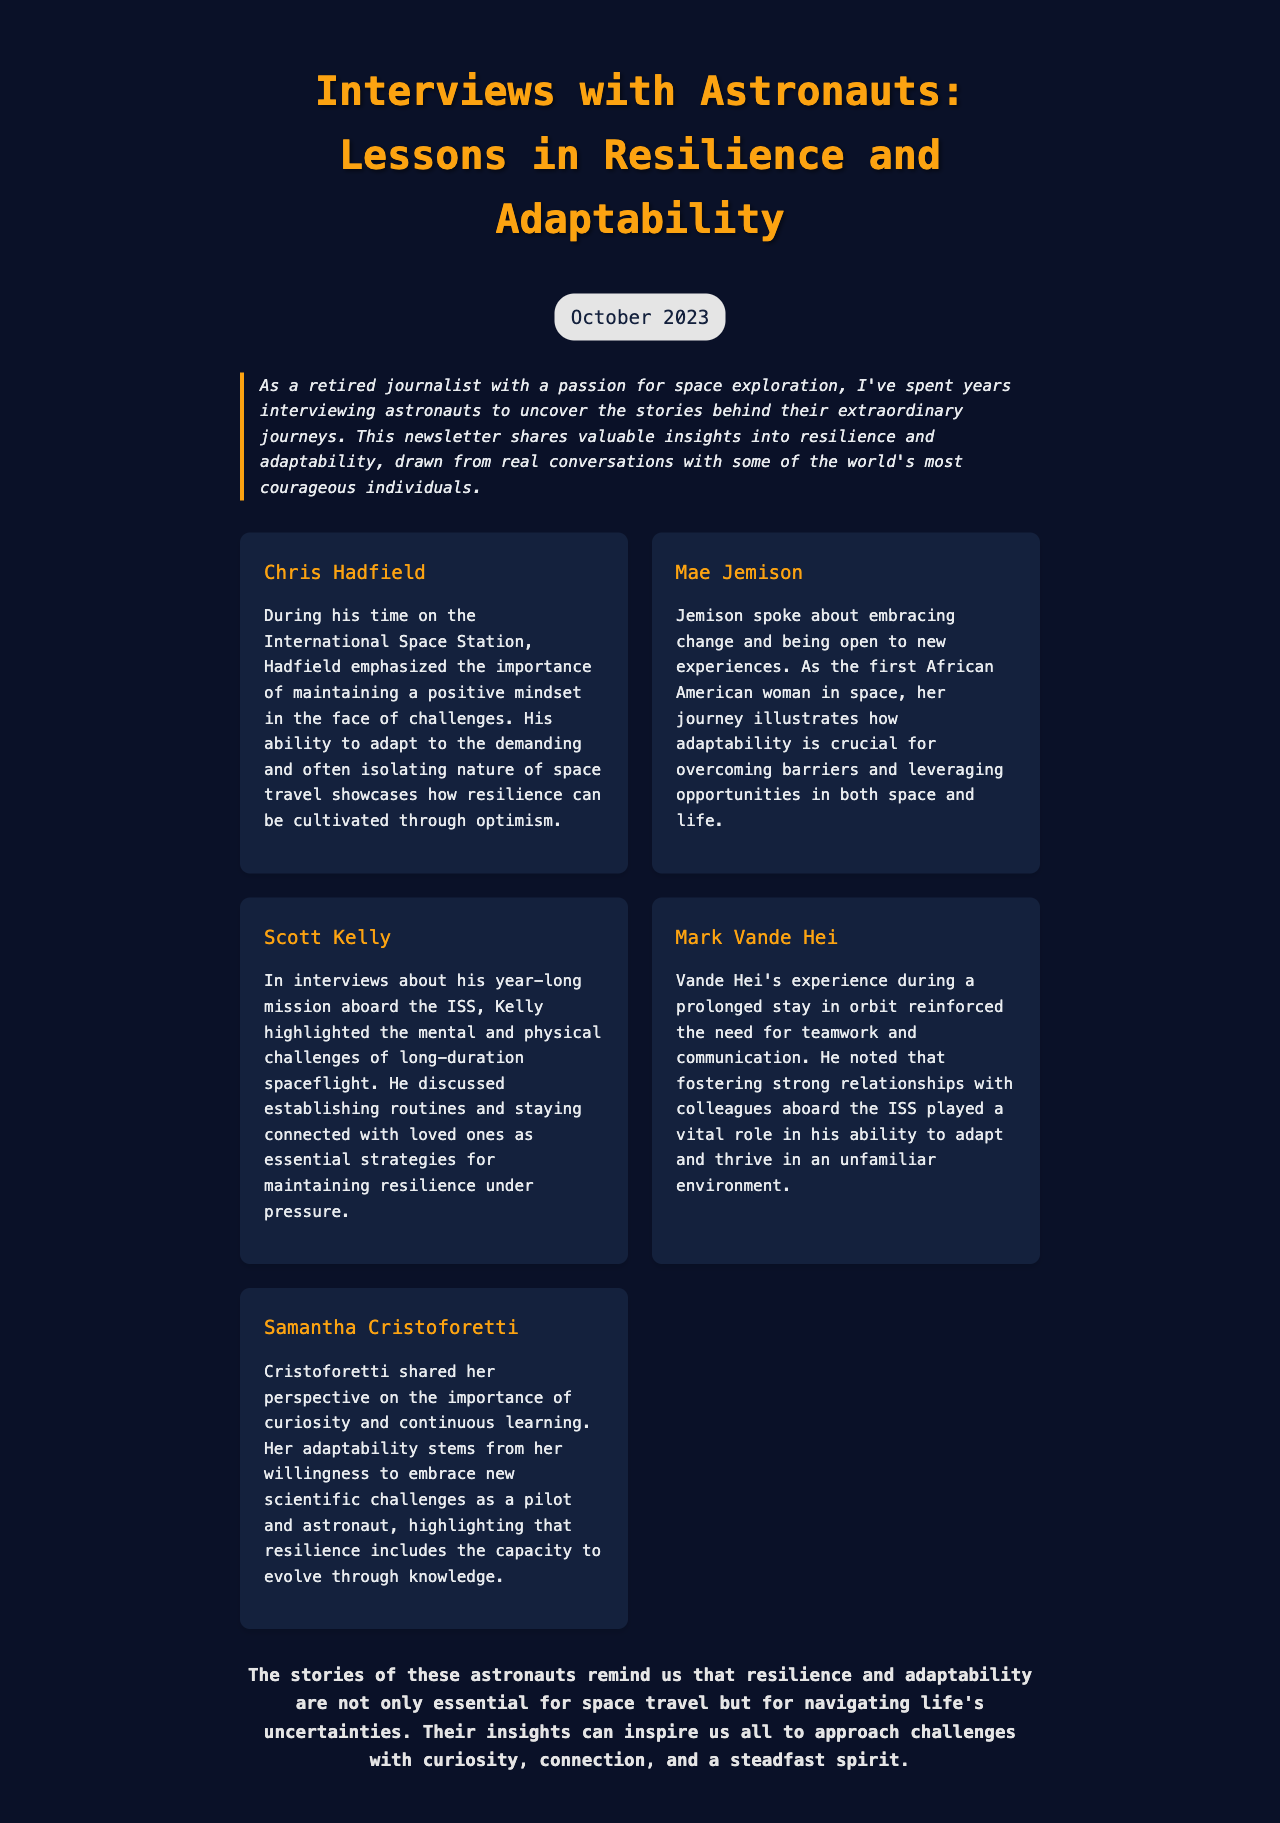What is the title of the newsletter? The title of the newsletter is prominently displayed at the top of the document.
Answer: Interviews with Astronauts: Lessons in Resilience and Adaptability What month and year was this newsletter published? The date of publication is indicated near the title, showing when the newsletter was made available.
Answer: October 2023 Who is the first astronaut mentioned in the insights? The astronauts are listed in insight cards, with their names at the top of each card.
Answer: Chris Hadfield What strategy did Scott Kelly discuss to maintain resilience? The document mentions specific strategies shared by each astronaut for resilience, specifically for Kelly.
Answer: Establishing routines Which astronaut emphasized curiosity and continuous learning? Each insight card details what each astronaut highlighted, and one mentions curiosity directly.
Answer: Samantha Cristoforetti How does Mae Jemison view adaptability? The insights in the document provide her perspective on adaptability in the context of her experiences.
Answer: Embracing change What is the main lesson highlighted in the conclusion? The conclusion summarizes the key takeaway from the astronauts' stories regarding broader life implications.
Answer: Resilience and adaptability How does Mark Vande Hei describe the importance of teamwork? His insights describe how relationships amongst colleagues support adaptability, which is clarified in the text.
Answer: Vital role What type of experience did Scott Kelly's ISS mission involve? The insights highlight specific attributes of his mission, which describe its nature and impact.
Answer: Year-long mission 